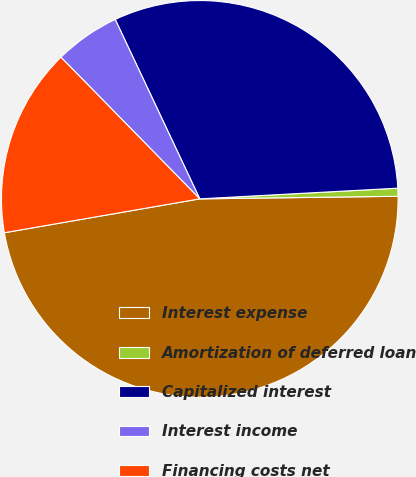<chart> <loc_0><loc_0><loc_500><loc_500><pie_chart><fcel>Interest expense<fcel>Amortization of deferred loan<fcel>Capitalized interest<fcel>Interest income<fcel>Financing costs net<nl><fcel>47.47%<fcel>0.65%<fcel>31.15%<fcel>5.33%<fcel>15.39%<nl></chart> 